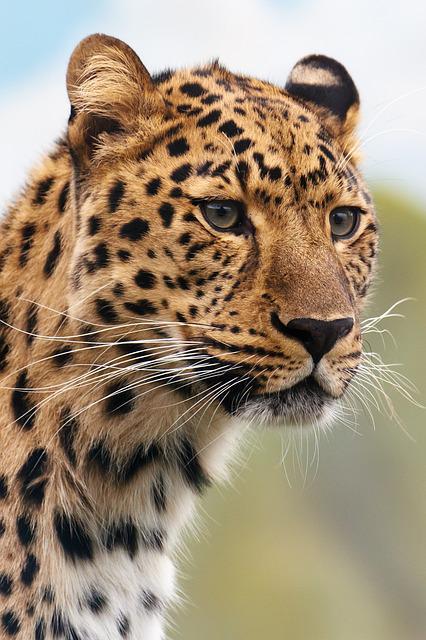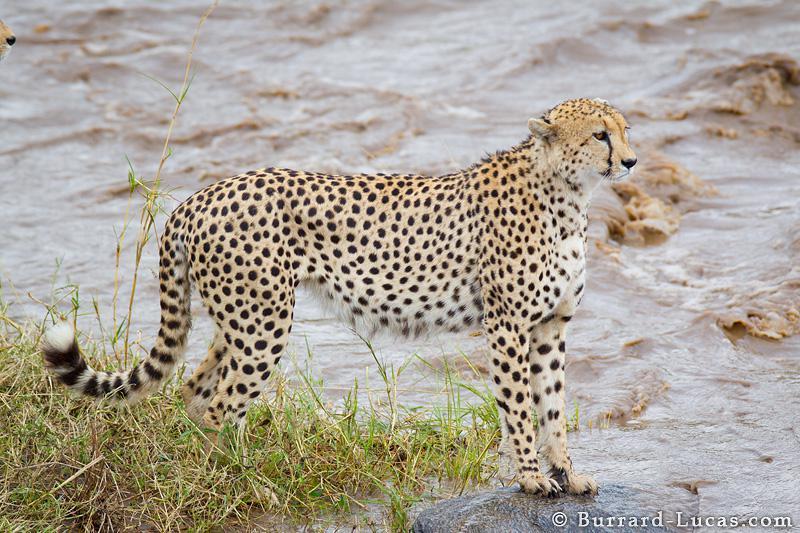The first image is the image on the left, the second image is the image on the right. Examine the images to the left and right. Is the description "Each image features one spotted wildcat and a body of water, and in one image, the cat is actually drinking at the edge of the water." accurate? Answer yes or no. No. The first image is the image on the left, the second image is the image on the right. Analyze the images presented: Is the assertion "The left image contains one cheetah standing on the bank of a lake drinking water." valid? Answer yes or no. No. 